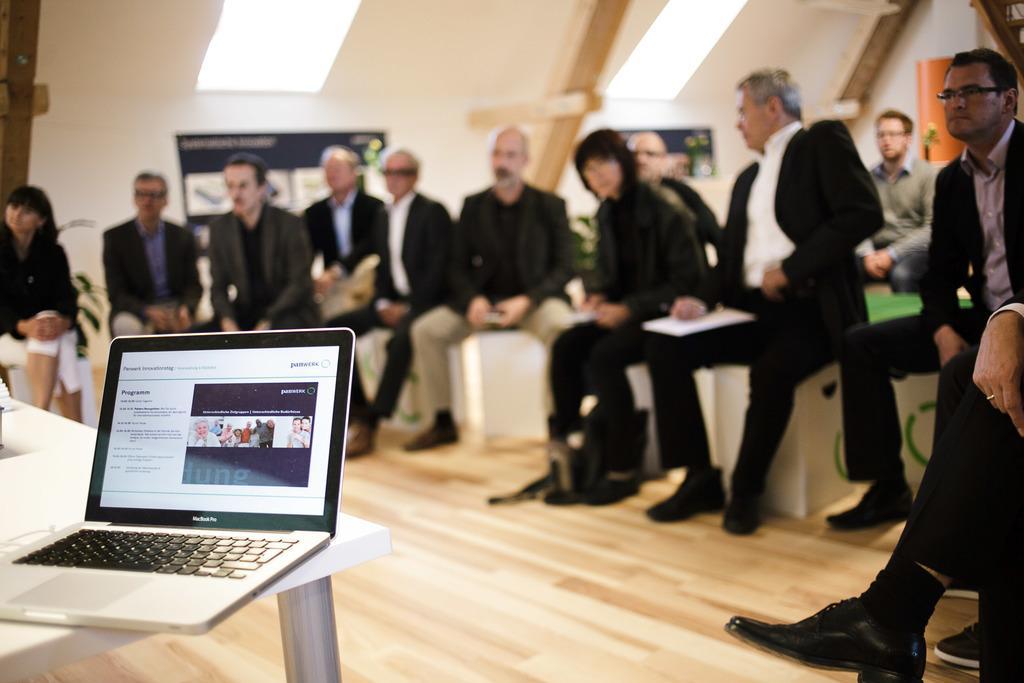How would you summarize this image in a sentence or two? Here people are sitting, this is laptop on the table. 